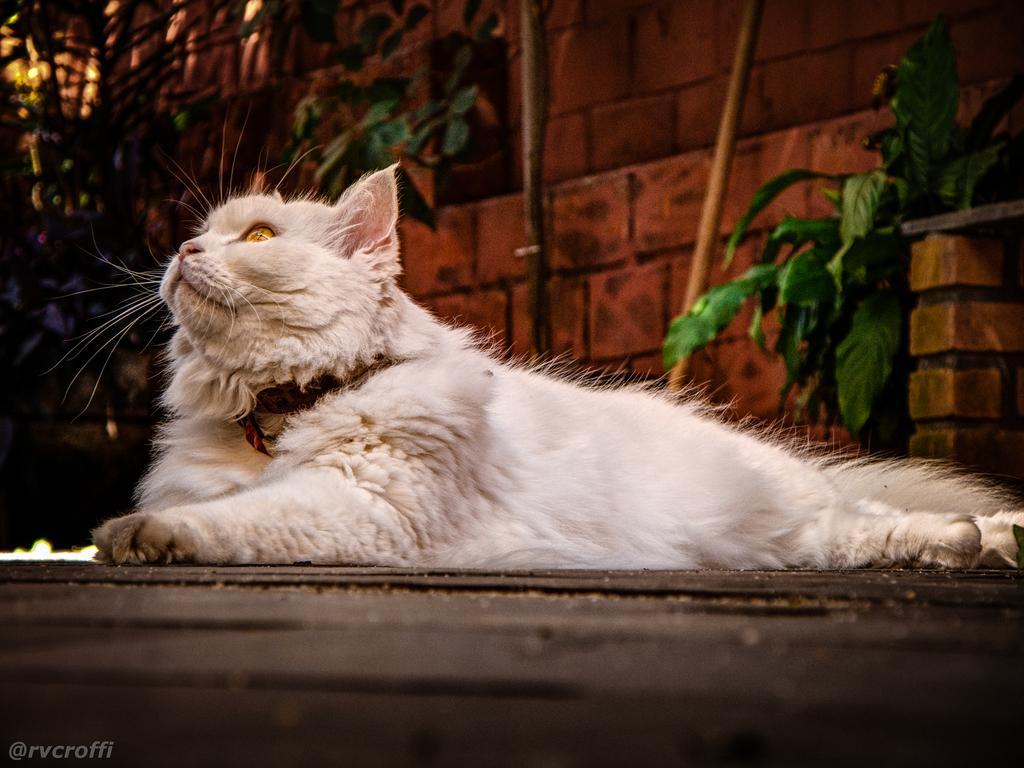Please provide a concise description of this image. In this image I can see a white color cat is laying on the ground and looking at the upwards. In the background there is a red color wall and some plants. 